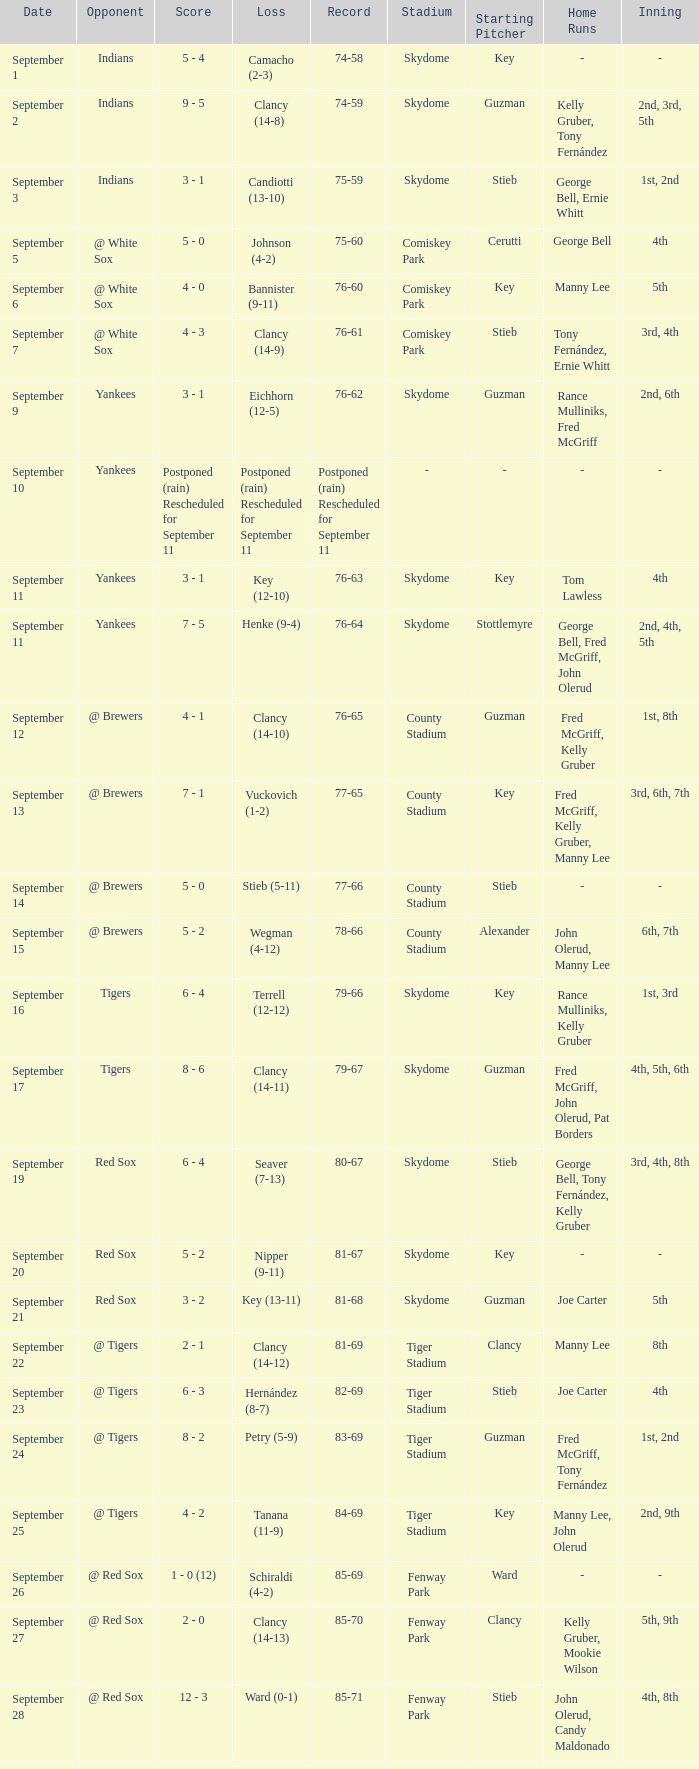Who was the Blue Jays opponent when their record was 84-69? @ Tigers. 